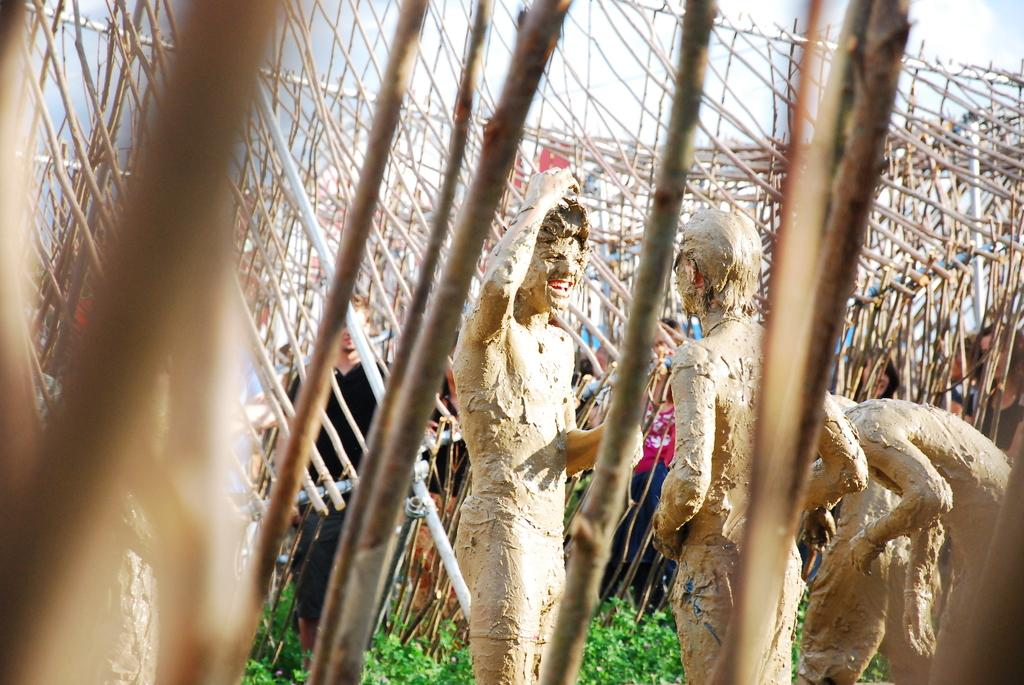What is the main object in the image? There is a pole in the image. What else can be seen in the image besides the pole? There are wooden sticks, grass, people, and the sky visible in the image. Can you describe the people in the image? There are people standing in the image. What is the background of the image? The sky is visible in the background of the image. How many horses are present in the image? There are no horses present in the image. What type of chair can be seen in the image? There is no chair present in the image. 